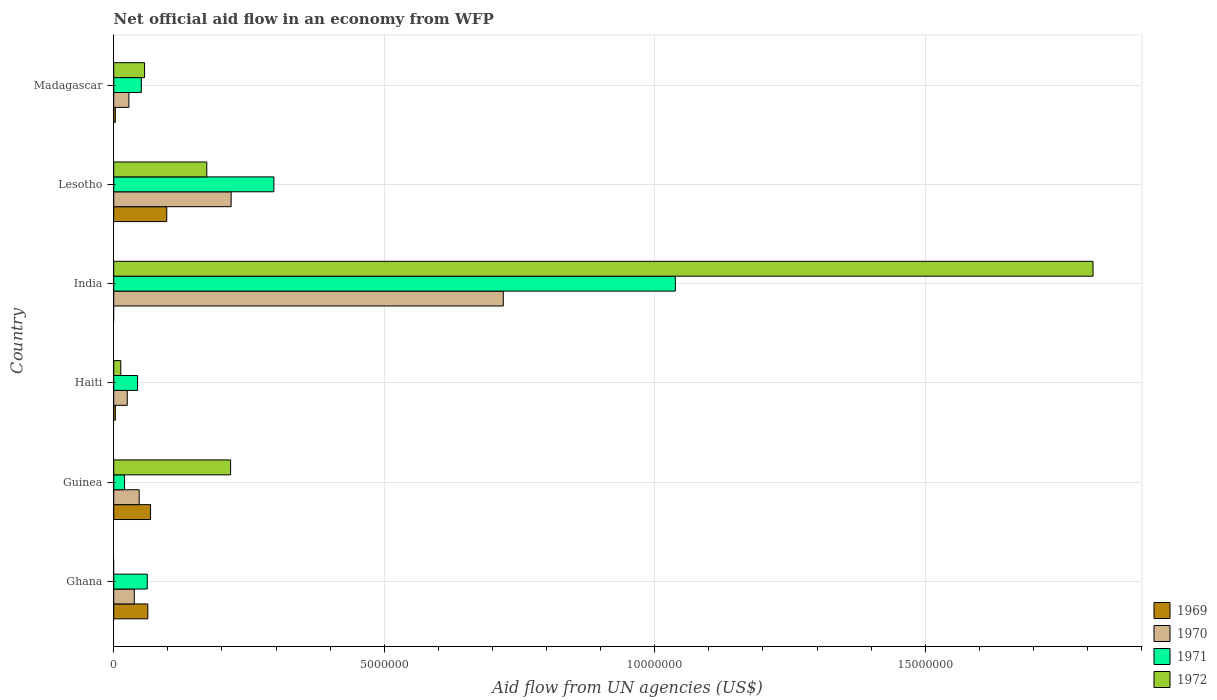How many different coloured bars are there?
Your response must be concise. 4. How many groups of bars are there?
Your answer should be very brief. 6. How many bars are there on the 2nd tick from the top?
Provide a succinct answer. 4. What is the label of the 5th group of bars from the top?
Keep it short and to the point. Guinea. What is the net official aid flow in 1971 in Ghana?
Provide a short and direct response. 6.20e+05. Across all countries, what is the maximum net official aid flow in 1971?
Offer a very short reply. 1.04e+07. Across all countries, what is the minimum net official aid flow in 1971?
Ensure brevity in your answer.  2.00e+05. In which country was the net official aid flow in 1969 maximum?
Provide a succinct answer. Lesotho. What is the total net official aid flow in 1969 in the graph?
Offer a terse response. 2.35e+06. What is the difference between the net official aid flow in 1972 in Guinea and that in Madagascar?
Your answer should be very brief. 1.59e+06. What is the difference between the net official aid flow in 1972 in Haiti and the net official aid flow in 1970 in Madagascar?
Your answer should be very brief. -1.50e+05. What is the average net official aid flow in 1970 per country?
Your answer should be compact. 1.79e+06. What is the difference between the net official aid flow in 1970 and net official aid flow in 1972 in Lesotho?
Your response must be concise. 4.50e+05. In how many countries, is the net official aid flow in 1971 greater than 12000000 US$?
Make the answer very short. 0. What is the ratio of the net official aid flow in 1971 in Guinea to that in Haiti?
Your response must be concise. 0.45. Is the difference between the net official aid flow in 1970 in Guinea and Haiti greater than the difference between the net official aid flow in 1972 in Guinea and Haiti?
Make the answer very short. No. What is the difference between the highest and the second highest net official aid flow in 1972?
Offer a very short reply. 1.59e+07. What is the difference between the highest and the lowest net official aid flow in 1972?
Your answer should be very brief. 1.81e+07. Is the sum of the net official aid flow in 1970 in India and Lesotho greater than the maximum net official aid flow in 1969 across all countries?
Your response must be concise. Yes. Is it the case that in every country, the sum of the net official aid flow in 1972 and net official aid flow in 1970 is greater than the net official aid flow in 1971?
Ensure brevity in your answer.  No. How many bars are there?
Your response must be concise. 22. How many countries are there in the graph?
Your answer should be very brief. 6. Are the values on the major ticks of X-axis written in scientific E-notation?
Give a very brief answer. No. Does the graph contain any zero values?
Provide a short and direct response. Yes. Where does the legend appear in the graph?
Keep it short and to the point. Bottom right. What is the title of the graph?
Offer a very short reply. Net official aid flow in an economy from WFP. Does "1964" appear as one of the legend labels in the graph?
Your response must be concise. No. What is the label or title of the X-axis?
Your response must be concise. Aid flow from UN agencies (US$). What is the Aid flow from UN agencies (US$) in 1969 in Ghana?
Keep it short and to the point. 6.30e+05. What is the Aid flow from UN agencies (US$) of 1971 in Ghana?
Your response must be concise. 6.20e+05. What is the Aid flow from UN agencies (US$) in 1969 in Guinea?
Offer a very short reply. 6.80e+05. What is the Aid flow from UN agencies (US$) of 1972 in Guinea?
Offer a very short reply. 2.16e+06. What is the Aid flow from UN agencies (US$) in 1969 in Haiti?
Your answer should be compact. 3.00e+04. What is the Aid flow from UN agencies (US$) in 1970 in Haiti?
Your answer should be very brief. 2.50e+05. What is the Aid flow from UN agencies (US$) of 1971 in Haiti?
Your answer should be compact. 4.40e+05. What is the Aid flow from UN agencies (US$) of 1969 in India?
Your answer should be very brief. 0. What is the Aid flow from UN agencies (US$) in 1970 in India?
Your response must be concise. 7.20e+06. What is the Aid flow from UN agencies (US$) of 1971 in India?
Your answer should be very brief. 1.04e+07. What is the Aid flow from UN agencies (US$) in 1972 in India?
Provide a succinct answer. 1.81e+07. What is the Aid flow from UN agencies (US$) of 1969 in Lesotho?
Keep it short and to the point. 9.80e+05. What is the Aid flow from UN agencies (US$) in 1970 in Lesotho?
Your answer should be compact. 2.17e+06. What is the Aid flow from UN agencies (US$) of 1971 in Lesotho?
Offer a terse response. 2.96e+06. What is the Aid flow from UN agencies (US$) of 1972 in Lesotho?
Provide a succinct answer. 1.72e+06. What is the Aid flow from UN agencies (US$) of 1969 in Madagascar?
Your answer should be very brief. 3.00e+04. What is the Aid flow from UN agencies (US$) in 1970 in Madagascar?
Give a very brief answer. 2.80e+05. What is the Aid flow from UN agencies (US$) in 1971 in Madagascar?
Provide a succinct answer. 5.10e+05. What is the Aid flow from UN agencies (US$) in 1972 in Madagascar?
Ensure brevity in your answer.  5.70e+05. Across all countries, what is the maximum Aid flow from UN agencies (US$) of 1969?
Offer a very short reply. 9.80e+05. Across all countries, what is the maximum Aid flow from UN agencies (US$) of 1970?
Make the answer very short. 7.20e+06. Across all countries, what is the maximum Aid flow from UN agencies (US$) of 1971?
Offer a terse response. 1.04e+07. Across all countries, what is the maximum Aid flow from UN agencies (US$) of 1972?
Keep it short and to the point. 1.81e+07. Across all countries, what is the minimum Aid flow from UN agencies (US$) of 1969?
Provide a succinct answer. 0. Across all countries, what is the minimum Aid flow from UN agencies (US$) of 1971?
Your answer should be very brief. 2.00e+05. What is the total Aid flow from UN agencies (US$) of 1969 in the graph?
Make the answer very short. 2.35e+06. What is the total Aid flow from UN agencies (US$) of 1970 in the graph?
Your response must be concise. 1.08e+07. What is the total Aid flow from UN agencies (US$) of 1971 in the graph?
Your answer should be compact. 1.51e+07. What is the total Aid flow from UN agencies (US$) of 1972 in the graph?
Provide a short and direct response. 2.27e+07. What is the difference between the Aid flow from UN agencies (US$) in 1969 in Ghana and that in Guinea?
Provide a short and direct response. -5.00e+04. What is the difference between the Aid flow from UN agencies (US$) in 1970 in Ghana and that in Guinea?
Your answer should be very brief. -9.00e+04. What is the difference between the Aid flow from UN agencies (US$) in 1969 in Ghana and that in Haiti?
Ensure brevity in your answer.  6.00e+05. What is the difference between the Aid flow from UN agencies (US$) of 1971 in Ghana and that in Haiti?
Provide a short and direct response. 1.80e+05. What is the difference between the Aid flow from UN agencies (US$) in 1970 in Ghana and that in India?
Your answer should be very brief. -6.82e+06. What is the difference between the Aid flow from UN agencies (US$) of 1971 in Ghana and that in India?
Your response must be concise. -9.76e+06. What is the difference between the Aid flow from UN agencies (US$) in 1969 in Ghana and that in Lesotho?
Ensure brevity in your answer.  -3.50e+05. What is the difference between the Aid flow from UN agencies (US$) of 1970 in Ghana and that in Lesotho?
Ensure brevity in your answer.  -1.79e+06. What is the difference between the Aid flow from UN agencies (US$) in 1971 in Ghana and that in Lesotho?
Offer a very short reply. -2.34e+06. What is the difference between the Aid flow from UN agencies (US$) in 1969 in Guinea and that in Haiti?
Keep it short and to the point. 6.50e+05. What is the difference between the Aid flow from UN agencies (US$) of 1972 in Guinea and that in Haiti?
Keep it short and to the point. 2.03e+06. What is the difference between the Aid flow from UN agencies (US$) of 1970 in Guinea and that in India?
Your answer should be very brief. -6.73e+06. What is the difference between the Aid flow from UN agencies (US$) of 1971 in Guinea and that in India?
Provide a succinct answer. -1.02e+07. What is the difference between the Aid flow from UN agencies (US$) in 1972 in Guinea and that in India?
Offer a very short reply. -1.59e+07. What is the difference between the Aid flow from UN agencies (US$) of 1969 in Guinea and that in Lesotho?
Provide a short and direct response. -3.00e+05. What is the difference between the Aid flow from UN agencies (US$) of 1970 in Guinea and that in Lesotho?
Offer a very short reply. -1.70e+06. What is the difference between the Aid flow from UN agencies (US$) in 1971 in Guinea and that in Lesotho?
Provide a short and direct response. -2.76e+06. What is the difference between the Aid flow from UN agencies (US$) in 1972 in Guinea and that in Lesotho?
Provide a short and direct response. 4.40e+05. What is the difference between the Aid flow from UN agencies (US$) in 1969 in Guinea and that in Madagascar?
Give a very brief answer. 6.50e+05. What is the difference between the Aid flow from UN agencies (US$) of 1971 in Guinea and that in Madagascar?
Provide a short and direct response. -3.10e+05. What is the difference between the Aid flow from UN agencies (US$) of 1972 in Guinea and that in Madagascar?
Your answer should be compact. 1.59e+06. What is the difference between the Aid flow from UN agencies (US$) of 1970 in Haiti and that in India?
Provide a short and direct response. -6.95e+06. What is the difference between the Aid flow from UN agencies (US$) of 1971 in Haiti and that in India?
Offer a terse response. -9.94e+06. What is the difference between the Aid flow from UN agencies (US$) in 1972 in Haiti and that in India?
Offer a very short reply. -1.80e+07. What is the difference between the Aid flow from UN agencies (US$) of 1969 in Haiti and that in Lesotho?
Your response must be concise. -9.50e+05. What is the difference between the Aid flow from UN agencies (US$) of 1970 in Haiti and that in Lesotho?
Offer a very short reply. -1.92e+06. What is the difference between the Aid flow from UN agencies (US$) of 1971 in Haiti and that in Lesotho?
Provide a short and direct response. -2.52e+06. What is the difference between the Aid flow from UN agencies (US$) of 1972 in Haiti and that in Lesotho?
Ensure brevity in your answer.  -1.59e+06. What is the difference between the Aid flow from UN agencies (US$) of 1969 in Haiti and that in Madagascar?
Your answer should be compact. 0. What is the difference between the Aid flow from UN agencies (US$) in 1972 in Haiti and that in Madagascar?
Your answer should be compact. -4.40e+05. What is the difference between the Aid flow from UN agencies (US$) of 1970 in India and that in Lesotho?
Your answer should be very brief. 5.03e+06. What is the difference between the Aid flow from UN agencies (US$) in 1971 in India and that in Lesotho?
Make the answer very short. 7.42e+06. What is the difference between the Aid flow from UN agencies (US$) of 1972 in India and that in Lesotho?
Ensure brevity in your answer.  1.64e+07. What is the difference between the Aid flow from UN agencies (US$) in 1970 in India and that in Madagascar?
Your answer should be very brief. 6.92e+06. What is the difference between the Aid flow from UN agencies (US$) in 1971 in India and that in Madagascar?
Provide a short and direct response. 9.87e+06. What is the difference between the Aid flow from UN agencies (US$) of 1972 in India and that in Madagascar?
Provide a succinct answer. 1.75e+07. What is the difference between the Aid flow from UN agencies (US$) in 1969 in Lesotho and that in Madagascar?
Give a very brief answer. 9.50e+05. What is the difference between the Aid flow from UN agencies (US$) of 1970 in Lesotho and that in Madagascar?
Give a very brief answer. 1.89e+06. What is the difference between the Aid flow from UN agencies (US$) in 1971 in Lesotho and that in Madagascar?
Make the answer very short. 2.45e+06. What is the difference between the Aid flow from UN agencies (US$) of 1972 in Lesotho and that in Madagascar?
Make the answer very short. 1.15e+06. What is the difference between the Aid flow from UN agencies (US$) of 1969 in Ghana and the Aid flow from UN agencies (US$) of 1970 in Guinea?
Your answer should be compact. 1.60e+05. What is the difference between the Aid flow from UN agencies (US$) of 1969 in Ghana and the Aid flow from UN agencies (US$) of 1971 in Guinea?
Provide a short and direct response. 4.30e+05. What is the difference between the Aid flow from UN agencies (US$) in 1969 in Ghana and the Aid flow from UN agencies (US$) in 1972 in Guinea?
Offer a very short reply. -1.53e+06. What is the difference between the Aid flow from UN agencies (US$) in 1970 in Ghana and the Aid flow from UN agencies (US$) in 1971 in Guinea?
Provide a succinct answer. 1.80e+05. What is the difference between the Aid flow from UN agencies (US$) in 1970 in Ghana and the Aid flow from UN agencies (US$) in 1972 in Guinea?
Your response must be concise. -1.78e+06. What is the difference between the Aid flow from UN agencies (US$) in 1971 in Ghana and the Aid flow from UN agencies (US$) in 1972 in Guinea?
Give a very brief answer. -1.54e+06. What is the difference between the Aid flow from UN agencies (US$) of 1970 in Ghana and the Aid flow from UN agencies (US$) of 1972 in Haiti?
Ensure brevity in your answer.  2.50e+05. What is the difference between the Aid flow from UN agencies (US$) of 1969 in Ghana and the Aid flow from UN agencies (US$) of 1970 in India?
Your response must be concise. -6.57e+06. What is the difference between the Aid flow from UN agencies (US$) in 1969 in Ghana and the Aid flow from UN agencies (US$) in 1971 in India?
Keep it short and to the point. -9.75e+06. What is the difference between the Aid flow from UN agencies (US$) of 1969 in Ghana and the Aid flow from UN agencies (US$) of 1972 in India?
Your answer should be compact. -1.75e+07. What is the difference between the Aid flow from UN agencies (US$) of 1970 in Ghana and the Aid flow from UN agencies (US$) of 1971 in India?
Your answer should be compact. -1.00e+07. What is the difference between the Aid flow from UN agencies (US$) of 1970 in Ghana and the Aid flow from UN agencies (US$) of 1972 in India?
Provide a short and direct response. -1.77e+07. What is the difference between the Aid flow from UN agencies (US$) in 1971 in Ghana and the Aid flow from UN agencies (US$) in 1972 in India?
Make the answer very short. -1.75e+07. What is the difference between the Aid flow from UN agencies (US$) in 1969 in Ghana and the Aid flow from UN agencies (US$) in 1970 in Lesotho?
Provide a succinct answer. -1.54e+06. What is the difference between the Aid flow from UN agencies (US$) in 1969 in Ghana and the Aid flow from UN agencies (US$) in 1971 in Lesotho?
Give a very brief answer. -2.33e+06. What is the difference between the Aid flow from UN agencies (US$) in 1969 in Ghana and the Aid flow from UN agencies (US$) in 1972 in Lesotho?
Offer a very short reply. -1.09e+06. What is the difference between the Aid flow from UN agencies (US$) in 1970 in Ghana and the Aid flow from UN agencies (US$) in 1971 in Lesotho?
Ensure brevity in your answer.  -2.58e+06. What is the difference between the Aid flow from UN agencies (US$) of 1970 in Ghana and the Aid flow from UN agencies (US$) of 1972 in Lesotho?
Ensure brevity in your answer.  -1.34e+06. What is the difference between the Aid flow from UN agencies (US$) in 1971 in Ghana and the Aid flow from UN agencies (US$) in 1972 in Lesotho?
Your response must be concise. -1.10e+06. What is the difference between the Aid flow from UN agencies (US$) in 1969 in Ghana and the Aid flow from UN agencies (US$) in 1970 in Madagascar?
Ensure brevity in your answer.  3.50e+05. What is the difference between the Aid flow from UN agencies (US$) of 1969 in Ghana and the Aid flow from UN agencies (US$) of 1971 in Madagascar?
Make the answer very short. 1.20e+05. What is the difference between the Aid flow from UN agencies (US$) in 1969 in Guinea and the Aid flow from UN agencies (US$) in 1970 in Haiti?
Offer a terse response. 4.30e+05. What is the difference between the Aid flow from UN agencies (US$) of 1969 in Guinea and the Aid flow from UN agencies (US$) of 1971 in Haiti?
Make the answer very short. 2.40e+05. What is the difference between the Aid flow from UN agencies (US$) in 1969 in Guinea and the Aid flow from UN agencies (US$) in 1972 in Haiti?
Give a very brief answer. 5.50e+05. What is the difference between the Aid flow from UN agencies (US$) of 1970 in Guinea and the Aid flow from UN agencies (US$) of 1971 in Haiti?
Provide a short and direct response. 3.00e+04. What is the difference between the Aid flow from UN agencies (US$) in 1970 in Guinea and the Aid flow from UN agencies (US$) in 1972 in Haiti?
Your answer should be compact. 3.40e+05. What is the difference between the Aid flow from UN agencies (US$) of 1969 in Guinea and the Aid flow from UN agencies (US$) of 1970 in India?
Provide a short and direct response. -6.52e+06. What is the difference between the Aid flow from UN agencies (US$) of 1969 in Guinea and the Aid flow from UN agencies (US$) of 1971 in India?
Give a very brief answer. -9.70e+06. What is the difference between the Aid flow from UN agencies (US$) in 1969 in Guinea and the Aid flow from UN agencies (US$) in 1972 in India?
Keep it short and to the point. -1.74e+07. What is the difference between the Aid flow from UN agencies (US$) in 1970 in Guinea and the Aid flow from UN agencies (US$) in 1971 in India?
Offer a terse response. -9.91e+06. What is the difference between the Aid flow from UN agencies (US$) of 1970 in Guinea and the Aid flow from UN agencies (US$) of 1972 in India?
Your answer should be compact. -1.76e+07. What is the difference between the Aid flow from UN agencies (US$) of 1971 in Guinea and the Aid flow from UN agencies (US$) of 1972 in India?
Your response must be concise. -1.79e+07. What is the difference between the Aid flow from UN agencies (US$) of 1969 in Guinea and the Aid flow from UN agencies (US$) of 1970 in Lesotho?
Ensure brevity in your answer.  -1.49e+06. What is the difference between the Aid flow from UN agencies (US$) in 1969 in Guinea and the Aid flow from UN agencies (US$) in 1971 in Lesotho?
Your answer should be compact. -2.28e+06. What is the difference between the Aid flow from UN agencies (US$) in 1969 in Guinea and the Aid flow from UN agencies (US$) in 1972 in Lesotho?
Give a very brief answer. -1.04e+06. What is the difference between the Aid flow from UN agencies (US$) in 1970 in Guinea and the Aid flow from UN agencies (US$) in 1971 in Lesotho?
Offer a terse response. -2.49e+06. What is the difference between the Aid flow from UN agencies (US$) in 1970 in Guinea and the Aid flow from UN agencies (US$) in 1972 in Lesotho?
Provide a short and direct response. -1.25e+06. What is the difference between the Aid flow from UN agencies (US$) in 1971 in Guinea and the Aid flow from UN agencies (US$) in 1972 in Lesotho?
Your answer should be very brief. -1.52e+06. What is the difference between the Aid flow from UN agencies (US$) of 1969 in Guinea and the Aid flow from UN agencies (US$) of 1970 in Madagascar?
Give a very brief answer. 4.00e+05. What is the difference between the Aid flow from UN agencies (US$) in 1970 in Guinea and the Aid flow from UN agencies (US$) in 1972 in Madagascar?
Offer a terse response. -1.00e+05. What is the difference between the Aid flow from UN agencies (US$) of 1971 in Guinea and the Aid flow from UN agencies (US$) of 1972 in Madagascar?
Ensure brevity in your answer.  -3.70e+05. What is the difference between the Aid flow from UN agencies (US$) in 1969 in Haiti and the Aid flow from UN agencies (US$) in 1970 in India?
Make the answer very short. -7.17e+06. What is the difference between the Aid flow from UN agencies (US$) in 1969 in Haiti and the Aid flow from UN agencies (US$) in 1971 in India?
Keep it short and to the point. -1.04e+07. What is the difference between the Aid flow from UN agencies (US$) of 1969 in Haiti and the Aid flow from UN agencies (US$) of 1972 in India?
Make the answer very short. -1.81e+07. What is the difference between the Aid flow from UN agencies (US$) of 1970 in Haiti and the Aid flow from UN agencies (US$) of 1971 in India?
Offer a terse response. -1.01e+07. What is the difference between the Aid flow from UN agencies (US$) in 1970 in Haiti and the Aid flow from UN agencies (US$) in 1972 in India?
Your answer should be very brief. -1.78e+07. What is the difference between the Aid flow from UN agencies (US$) of 1971 in Haiti and the Aid flow from UN agencies (US$) of 1972 in India?
Your answer should be very brief. -1.77e+07. What is the difference between the Aid flow from UN agencies (US$) of 1969 in Haiti and the Aid flow from UN agencies (US$) of 1970 in Lesotho?
Make the answer very short. -2.14e+06. What is the difference between the Aid flow from UN agencies (US$) in 1969 in Haiti and the Aid flow from UN agencies (US$) in 1971 in Lesotho?
Your response must be concise. -2.93e+06. What is the difference between the Aid flow from UN agencies (US$) in 1969 in Haiti and the Aid flow from UN agencies (US$) in 1972 in Lesotho?
Keep it short and to the point. -1.69e+06. What is the difference between the Aid flow from UN agencies (US$) in 1970 in Haiti and the Aid flow from UN agencies (US$) in 1971 in Lesotho?
Your answer should be very brief. -2.71e+06. What is the difference between the Aid flow from UN agencies (US$) in 1970 in Haiti and the Aid flow from UN agencies (US$) in 1972 in Lesotho?
Give a very brief answer. -1.47e+06. What is the difference between the Aid flow from UN agencies (US$) of 1971 in Haiti and the Aid flow from UN agencies (US$) of 1972 in Lesotho?
Provide a succinct answer. -1.28e+06. What is the difference between the Aid flow from UN agencies (US$) of 1969 in Haiti and the Aid flow from UN agencies (US$) of 1971 in Madagascar?
Offer a terse response. -4.80e+05. What is the difference between the Aid flow from UN agencies (US$) in 1969 in Haiti and the Aid flow from UN agencies (US$) in 1972 in Madagascar?
Keep it short and to the point. -5.40e+05. What is the difference between the Aid flow from UN agencies (US$) in 1970 in Haiti and the Aid flow from UN agencies (US$) in 1972 in Madagascar?
Make the answer very short. -3.20e+05. What is the difference between the Aid flow from UN agencies (US$) in 1971 in Haiti and the Aid flow from UN agencies (US$) in 1972 in Madagascar?
Make the answer very short. -1.30e+05. What is the difference between the Aid flow from UN agencies (US$) in 1970 in India and the Aid flow from UN agencies (US$) in 1971 in Lesotho?
Provide a succinct answer. 4.24e+06. What is the difference between the Aid flow from UN agencies (US$) of 1970 in India and the Aid flow from UN agencies (US$) of 1972 in Lesotho?
Ensure brevity in your answer.  5.48e+06. What is the difference between the Aid flow from UN agencies (US$) in 1971 in India and the Aid flow from UN agencies (US$) in 1972 in Lesotho?
Give a very brief answer. 8.66e+06. What is the difference between the Aid flow from UN agencies (US$) of 1970 in India and the Aid flow from UN agencies (US$) of 1971 in Madagascar?
Ensure brevity in your answer.  6.69e+06. What is the difference between the Aid flow from UN agencies (US$) of 1970 in India and the Aid flow from UN agencies (US$) of 1972 in Madagascar?
Provide a succinct answer. 6.63e+06. What is the difference between the Aid flow from UN agencies (US$) of 1971 in India and the Aid flow from UN agencies (US$) of 1972 in Madagascar?
Give a very brief answer. 9.81e+06. What is the difference between the Aid flow from UN agencies (US$) in 1969 in Lesotho and the Aid flow from UN agencies (US$) in 1970 in Madagascar?
Your answer should be compact. 7.00e+05. What is the difference between the Aid flow from UN agencies (US$) in 1969 in Lesotho and the Aid flow from UN agencies (US$) in 1971 in Madagascar?
Keep it short and to the point. 4.70e+05. What is the difference between the Aid flow from UN agencies (US$) in 1970 in Lesotho and the Aid flow from UN agencies (US$) in 1971 in Madagascar?
Provide a succinct answer. 1.66e+06. What is the difference between the Aid flow from UN agencies (US$) of 1970 in Lesotho and the Aid flow from UN agencies (US$) of 1972 in Madagascar?
Make the answer very short. 1.60e+06. What is the difference between the Aid flow from UN agencies (US$) of 1971 in Lesotho and the Aid flow from UN agencies (US$) of 1972 in Madagascar?
Your answer should be very brief. 2.39e+06. What is the average Aid flow from UN agencies (US$) of 1969 per country?
Give a very brief answer. 3.92e+05. What is the average Aid flow from UN agencies (US$) in 1970 per country?
Ensure brevity in your answer.  1.79e+06. What is the average Aid flow from UN agencies (US$) in 1971 per country?
Keep it short and to the point. 2.52e+06. What is the average Aid flow from UN agencies (US$) of 1972 per country?
Your answer should be compact. 3.78e+06. What is the difference between the Aid flow from UN agencies (US$) of 1969 and Aid flow from UN agencies (US$) of 1970 in Ghana?
Provide a succinct answer. 2.50e+05. What is the difference between the Aid flow from UN agencies (US$) of 1969 and Aid flow from UN agencies (US$) of 1971 in Ghana?
Provide a short and direct response. 10000. What is the difference between the Aid flow from UN agencies (US$) in 1970 and Aid flow from UN agencies (US$) in 1971 in Ghana?
Your answer should be very brief. -2.40e+05. What is the difference between the Aid flow from UN agencies (US$) of 1969 and Aid flow from UN agencies (US$) of 1972 in Guinea?
Make the answer very short. -1.48e+06. What is the difference between the Aid flow from UN agencies (US$) of 1970 and Aid flow from UN agencies (US$) of 1971 in Guinea?
Give a very brief answer. 2.70e+05. What is the difference between the Aid flow from UN agencies (US$) in 1970 and Aid flow from UN agencies (US$) in 1972 in Guinea?
Your response must be concise. -1.69e+06. What is the difference between the Aid flow from UN agencies (US$) in 1971 and Aid flow from UN agencies (US$) in 1972 in Guinea?
Keep it short and to the point. -1.96e+06. What is the difference between the Aid flow from UN agencies (US$) in 1969 and Aid flow from UN agencies (US$) in 1970 in Haiti?
Offer a terse response. -2.20e+05. What is the difference between the Aid flow from UN agencies (US$) of 1969 and Aid flow from UN agencies (US$) of 1971 in Haiti?
Provide a succinct answer. -4.10e+05. What is the difference between the Aid flow from UN agencies (US$) of 1969 and Aid flow from UN agencies (US$) of 1972 in Haiti?
Make the answer very short. -1.00e+05. What is the difference between the Aid flow from UN agencies (US$) of 1971 and Aid flow from UN agencies (US$) of 1972 in Haiti?
Ensure brevity in your answer.  3.10e+05. What is the difference between the Aid flow from UN agencies (US$) of 1970 and Aid flow from UN agencies (US$) of 1971 in India?
Provide a succinct answer. -3.18e+06. What is the difference between the Aid flow from UN agencies (US$) of 1970 and Aid flow from UN agencies (US$) of 1972 in India?
Provide a succinct answer. -1.09e+07. What is the difference between the Aid flow from UN agencies (US$) in 1971 and Aid flow from UN agencies (US$) in 1972 in India?
Keep it short and to the point. -7.72e+06. What is the difference between the Aid flow from UN agencies (US$) in 1969 and Aid flow from UN agencies (US$) in 1970 in Lesotho?
Your response must be concise. -1.19e+06. What is the difference between the Aid flow from UN agencies (US$) of 1969 and Aid flow from UN agencies (US$) of 1971 in Lesotho?
Provide a succinct answer. -1.98e+06. What is the difference between the Aid flow from UN agencies (US$) of 1969 and Aid flow from UN agencies (US$) of 1972 in Lesotho?
Give a very brief answer. -7.40e+05. What is the difference between the Aid flow from UN agencies (US$) of 1970 and Aid flow from UN agencies (US$) of 1971 in Lesotho?
Your response must be concise. -7.90e+05. What is the difference between the Aid flow from UN agencies (US$) of 1970 and Aid flow from UN agencies (US$) of 1972 in Lesotho?
Provide a succinct answer. 4.50e+05. What is the difference between the Aid flow from UN agencies (US$) of 1971 and Aid flow from UN agencies (US$) of 1972 in Lesotho?
Provide a succinct answer. 1.24e+06. What is the difference between the Aid flow from UN agencies (US$) of 1969 and Aid flow from UN agencies (US$) of 1971 in Madagascar?
Your answer should be compact. -4.80e+05. What is the difference between the Aid flow from UN agencies (US$) of 1969 and Aid flow from UN agencies (US$) of 1972 in Madagascar?
Make the answer very short. -5.40e+05. What is the difference between the Aid flow from UN agencies (US$) in 1970 and Aid flow from UN agencies (US$) in 1971 in Madagascar?
Provide a short and direct response. -2.30e+05. What is the difference between the Aid flow from UN agencies (US$) in 1971 and Aid flow from UN agencies (US$) in 1972 in Madagascar?
Keep it short and to the point. -6.00e+04. What is the ratio of the Aid flow from UN agencies (US$) in 1969 in Ghana to that in Guinea?
Keep it short and to the point. 0.93. What is the ratio of the Aid flow from UN agencies (US$) of 1970 in Ghana to that in Guinea?
Your answer should be compact. 0.81. What is the ratio of the Aid flow from UN agencies (US$) of 1971 in Ghana to that in Guinea?
Keep it short and to the point. 3.1. What is the ratio of the Aid flow from UN agencies (US$) in 1970 in Ghana to that in Haiti?
Your answer should be very brief. 1.52. What is the ratio of the Aid flow from UN agencies (US$) in 1971 in Ghana to that in Haiti?
Ensure brevity in your answer.  1.41. What is the ratio of the Aid flow from UN agencies (US$) in 1970 in Ghana to that in India?
Keep it short and to the point. 0.05. What is the ratio of the Aid flow from UN agencies (US$) of 1971 in Ghana to that in India?
Give a very brief answer. 0.06. What is the ratio of the Aid flow from UN agencies (US$) of 1969 in Ghana to that in Lesotho?
Offer a very short reply. 0.64. What is the ratio of the Aid flow from UN agencies (US$) of 1970 in Ghana to that in Lesotho?
Make the answer very short. 0.18. What is the ratio of the Aid flow from UN agencies (US$) of 1971 in Ghana to that in Lesotho?
Provide a short and direct response. 0.21. What is the ratio of the Aid flow from UN agencies (US$) in 1969 in Ghana to that in Madagascar?
Ensure brevity in your answer.  21. What is the ratio of the Aid flow from UN agencies (US$) of 1970 in Ghana to that in Madagascar?
Provide a short and direct response. 1.36. What is the ratio of the Aid flow from UN agencies (US$) in 1971 in Ghana to that in Madagascar?
Your response must be concise. 1.22. What is the ratio of the Aid flow from UN agencies (US$) of 1969 in Guinea to that in Haiti?
Your answer should be very brief. 22.67. What is the ratio of the Aid flow from UN agencies (US$) of 1970 in Guinea to that in Haiti?
Your answer should be compact. 1.88. What is the ratio of the Aid flow from UN agencies (US$) in 1971 in Guinea to that in Haiti?
Provide a succinct answer. 0.45. What is the ratio of the Aid flow from UN agencies (US$) in 1972 in Guinea to that in Haiti?
Keep it short and to the point. 16.62. What is the ratio of the Aid flow from UN agencies (US$) in 1970 in Guinea to that in India?
Ensure brevity in your answer.  0.07. What is the ratio of the Aid flow from UN agencies (US$) in 1971 in Guinea to that in India?
Provide a short and direct response. 0.02. What is the ratio of the Aid flow from UN agencies (US$) in 1972 in Guinea to that in India?
Your response must be concise. 0.12. What is the ratio of the Aid flow from UN agencies (US$) in 1969 in Guinea to that in Lesotho?
Your response must be concise. 0.69. What is the ratio of the Aid flow from UN agencies (US$) in 1970 in Guinea to that in Lesotho?
Provide a short and direct response. 0.22. What is the ratio of the Aid flow from UN agencies (US$) in 1971 in Guinea to that in Lesotho?
Ensure brevity in your answer.  0.07. What is the ratio of the Aid flow from UN agencies (US$) of 1972 in Guinea to that in Lesotho?
Keep it short and to the point. 1.26. What is the ratio of the Aid flow from UN agencies (US$) of 1969 in Guinea to that in Madagascar?
Keep it short and to the point. 22.67. What is the ratio of the Aid flow from UN agencies (US$) of 1970 in Guinea to that in Madagascar?
Provide a short and direct response. 1.68. What is the ratio of the Aid flow from UN agencies (US$) of 1971 in Guinea to that in Madagascar?
Give a very brief answer. 0.39. What is the ratio of the Aid flow from UN agencies (US$) in 1972 in Guinea to that in Madagascar?
Provide a short and direct response. 3.79. What is the ratio of the Aid flow from UN agencies (US$) in 1970 in Haiti to that in India?
Your answer should be very brief. 0.03. What is the ratio of the Aid flow from UN agencies (US$) of 1971 in Haiti to that in India?
Offer a terse response. 0.04. What is the ratio of the Aid flow from UN agencies (US$) of 1972 in Haiti to that in India?
Give a very brief answer. 0.01. What is the ratio of the Aid flow from UN agencies (US$) of 1969 in Haiti to that in Lesotho?
Give a very brief answer. 0.03. What is the ratio of the Aid flow from UN agencies (US$) in 1970 in Haiti to that in Lesotho?
Keep it short and to the point. 0.12. What is the ratio of the Aid flow from UN agencies (US$) of 1971 in Haiti to that in Lesotho?
Offer a terse response. 0.15. What is the ratio of the Aid flow from UN agencies (US$) in 1972 in Haiti to that in Lesotho?
Make the answer very short. 0.08. What is the ratio of the Aid flow from UN agencies (US$) in 1969 in Haiti to that in Madagascar?
Your answer should be compact. 1. What is the ratio of the Aid flow from UN agencies (US$) in 1970 in Haiti to that in Madagascar?
Offer a terse response. 0.89. What is the ratio of the Aid flow from UN agencies (US$) of 1971 in Haiti to that in Madagascar?
Your response must be concise. 0.86. What is the ratio of the Aid flow from UN agencies (US$) in 1972 in Haiti to that in Madagascar?
Your answer should be compact. 0.23. What is the ratio of the Aid flow from UN agencies (US$) in 1970 in India to that in Lesotho?
Give a very brief answer. 3.32. What is the ratio of the Aid flow from UN agencies (US$) of 1971 in India to that in Lesotho?
Your response must be concise. 3.51. What is the ratio of the Aid flow from UN agencies (US$) of 1972 in India to that in Lesotho?
Provide a succinct answer. 10.52. What is the ratio of the Aid flow from UN agencies (US$) in 1970 in India to that in Madagascar?
Make the answer very short. 25.71. What is the ratio of the Aid flow from UN agencies (US$) of 1971 in India to that in Madagascar?
Your answer should be compact. 20.35. What is the ratio of the Aid flow from UN agencies (US$) in 1972 in India to that in Madagascar?
Ensure brevity in your answer.  31.75. What is the ratio of the Aid flow from UN agencies (US$) in 1969 in Lesotho to that in Madagascar?
Your answer should be very brief. 32.67. What is the ratio of the Aid flow from UN agencies (US$) of 1970 in Lesotho to that in Madagascar?
Your answer should be compact. 7.75. What is the ratio of the Aid flow from UN agencies (US$) of 1971 in Lesotho to that in Madagascar?
Provide a short and direct response. 5.8. What is the ratio of the Aid flow from UN agencies (US$) of 1972 in Lesotho to that in Madagascar?
Provide a succinct answer. 3.02. What is the difference between the highest and the second highest Aid flow from UN agencies (US$) of 1969?
Provide a short and direct response. 3.00e+05. What is the difference between the highest and the second highest Aid flow from UN agencies (US$) in 1970?
Provide a succinct answer. 5.03e+06. What is the difference between the highest and the second highest Aid flow from UN agencies (US$) in 1971?
Your response must be concise. 7.42e+06. What is the difference between the highest and the second highest Aid flow from UN agencies (US$) of 1972?
Your answer should be very brief. 1.59e+07. What is the difference between the highest and the lowest Aid flow from UN agencies (US$) in 1969?
Your answer should be very brief. 9.80e+05. What is the difference between the highest and the lowest Aid flow from UN agencies (US$) in 1970?
Your answer should be very brief. 6.95e+06. What is the difference between the highest and the lowest Aid flow from UN agencies (US$) of 1971?
Keep it short and to the point. 1.02e+07. What is the difference between the highest and the lowest Aid flow from UN agencies (US$) in 1972?
Provide a short and direct response. 1.81e+07. 